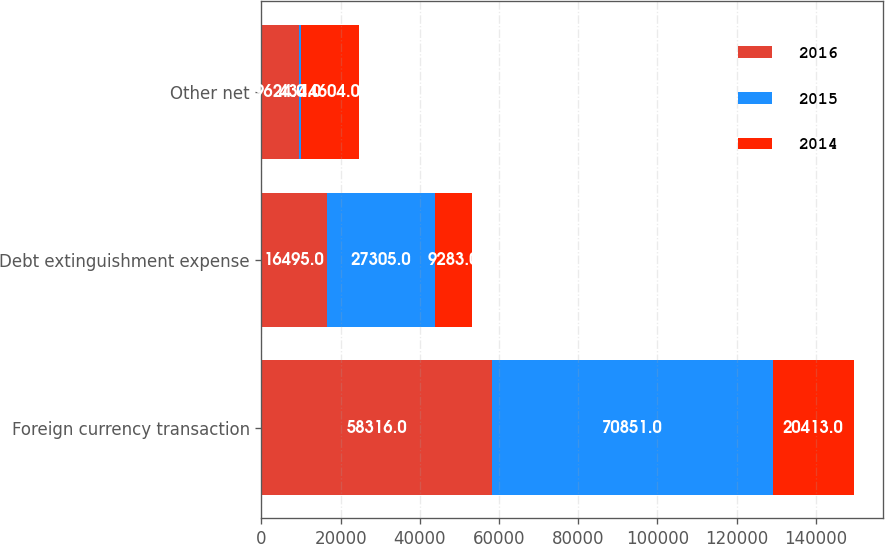Convert chart. <chart><loc_0><loc_0><loc_500><loc_500><stacked_bar_chart><ecel><fcel>Foreign currency transaction<fcel>Debt extinguishment expense<fcel>Other net<nl><fcel>2016<fcel>58316<fcel>16495<fcel>9624<nl><fcel>2015<fcel>70851<fcel>27305<fcel>434<nl><fcel>2014<fcel>20413<fcel>9283<fcel>14604<nl></chart> 